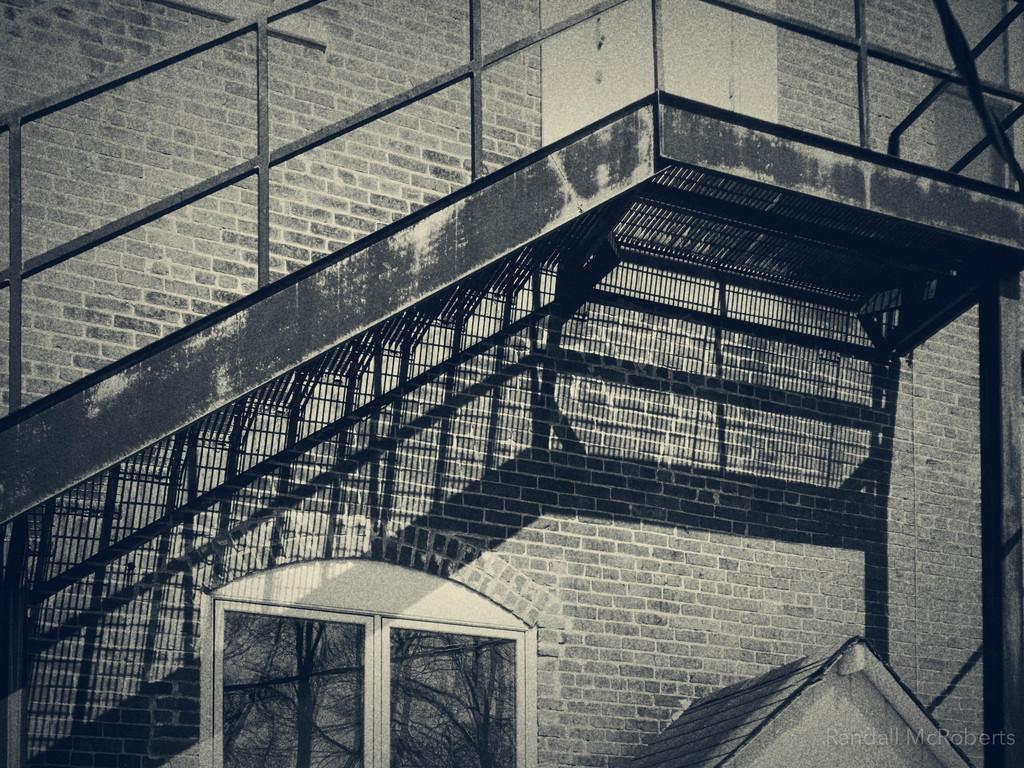Describe this image in one or two sentences. In this black and white image there is a building, in front of the building there are stairs. 